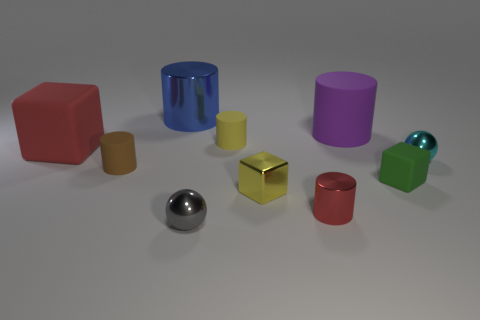Subtract 2 cylinders. How many cylinders are left? 3 Subtract all yellow cylinders. How many cylinders are left? 4 Subtract all yellow cylinders. How many cylinders are left? 4 Subtract all cyan cylinders. Subtract all yellow balls. How many cylinders are left? 5 Subtract all blocks. How many objects are left? 7 Add 4 small green matte cylinders. How many small green matte cylinders exist? 4 Subtract 1 gray balls. How many objects are left? 9 Subtract all big red blocks. Subtract all large purple cylinders. How many objects are left? 8 Add 7 cyan objects. How many cyan objects are left? 8 